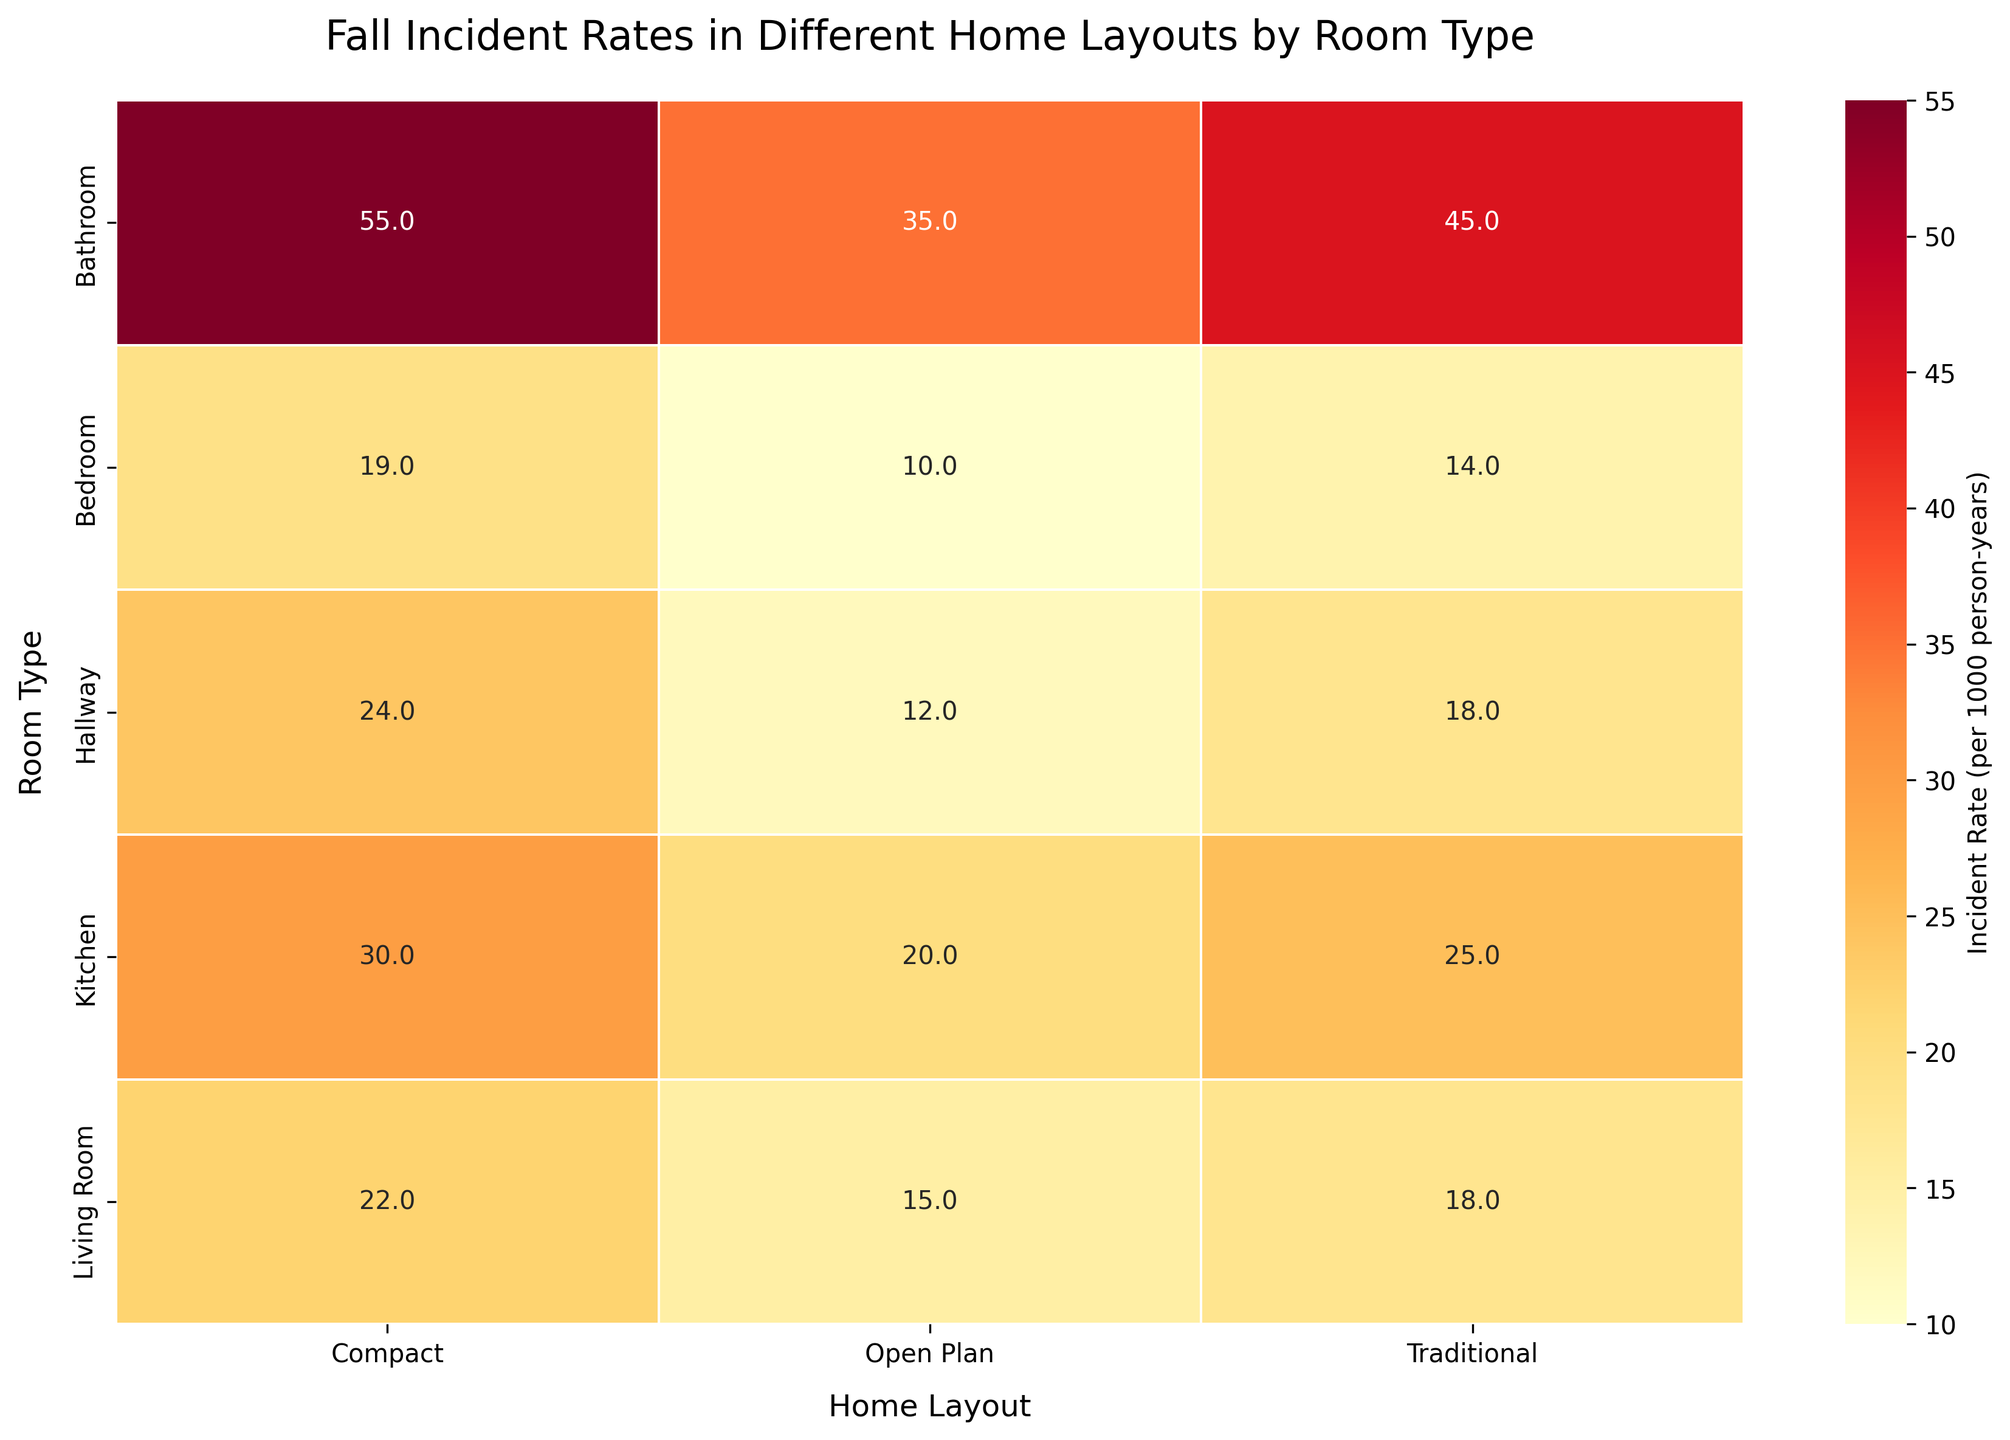What is the fall incident rate in the bathroom for a traditional home layout? Look for the bathroom row and the traditional column on the heatmap. The value where the two intersect is the fall incident rate for that room type and home layout combination.
Answer: 45 Which room type in the compact home layout has the highest fall incident rate? Identify the 'Compact' column and then compare the incident rates across the different rows (room types). The room type with the highest value in this column is the one with the highest fall incident rate.
Answer: Bathroom How does the fall incident rate in the living room compare between open plan and traditional layouts? Identify the values in the 'Living Room' row for both 'Open Plan' and 'Traditional' columns. Compare these values to see which is greater.
Answer: The rate is higher in the traditional layout What's the average fall incident rate for all types of home layouts in the kitchen? Locate the 'Kitchen' row and identify the values for each layout (20, 25, 30). Sum these values and divide by the number of values to find the average.
Answer: 25 Is the fall incident rate in the hallway of a compact home layout higher than in the open plan layout? Compare the values for 'Hallway' in the 'Compact' column and the 'Open Plan' column. Check whether the compact layout value is higher.
Answer: Yes, it is higher Which room type has the lowest fall incident rate in the open plan layout? Identify the values in the 'Open Plan' column. The row with the lowest value corresponds to the room type with the lowest fall incident rate in that layout.
Answer: Bedroom What's the difference in fall incident rates between the bathroom in the compact layout and the hallway in the traditional layout? Identify the values for 'Bathroom' in the 'Compact' column and 'Hallway' in the 'Traditional' column. Subtract the hallway value from the bathroom value.
Answer: 37 How does the incident rate in the kitchen for a traditional home layout compare to the incident rate in the bathroom for an open plan layout? Look at the values in the 'Kitchen' row and 'Traditional' column and the 'Bathroom' row and 'Open Plan' column. Compare these two values to see which is higher.
Answer: The rate is higher in the bathroom for an open plan layout What's the median fall incident rate for the bedroom across all home layouts? Identify the values in the 'Bedroom' row (10, 14, 19). Sort these values to find the median, which is the middle value in a sorted list.
Answer: 14 